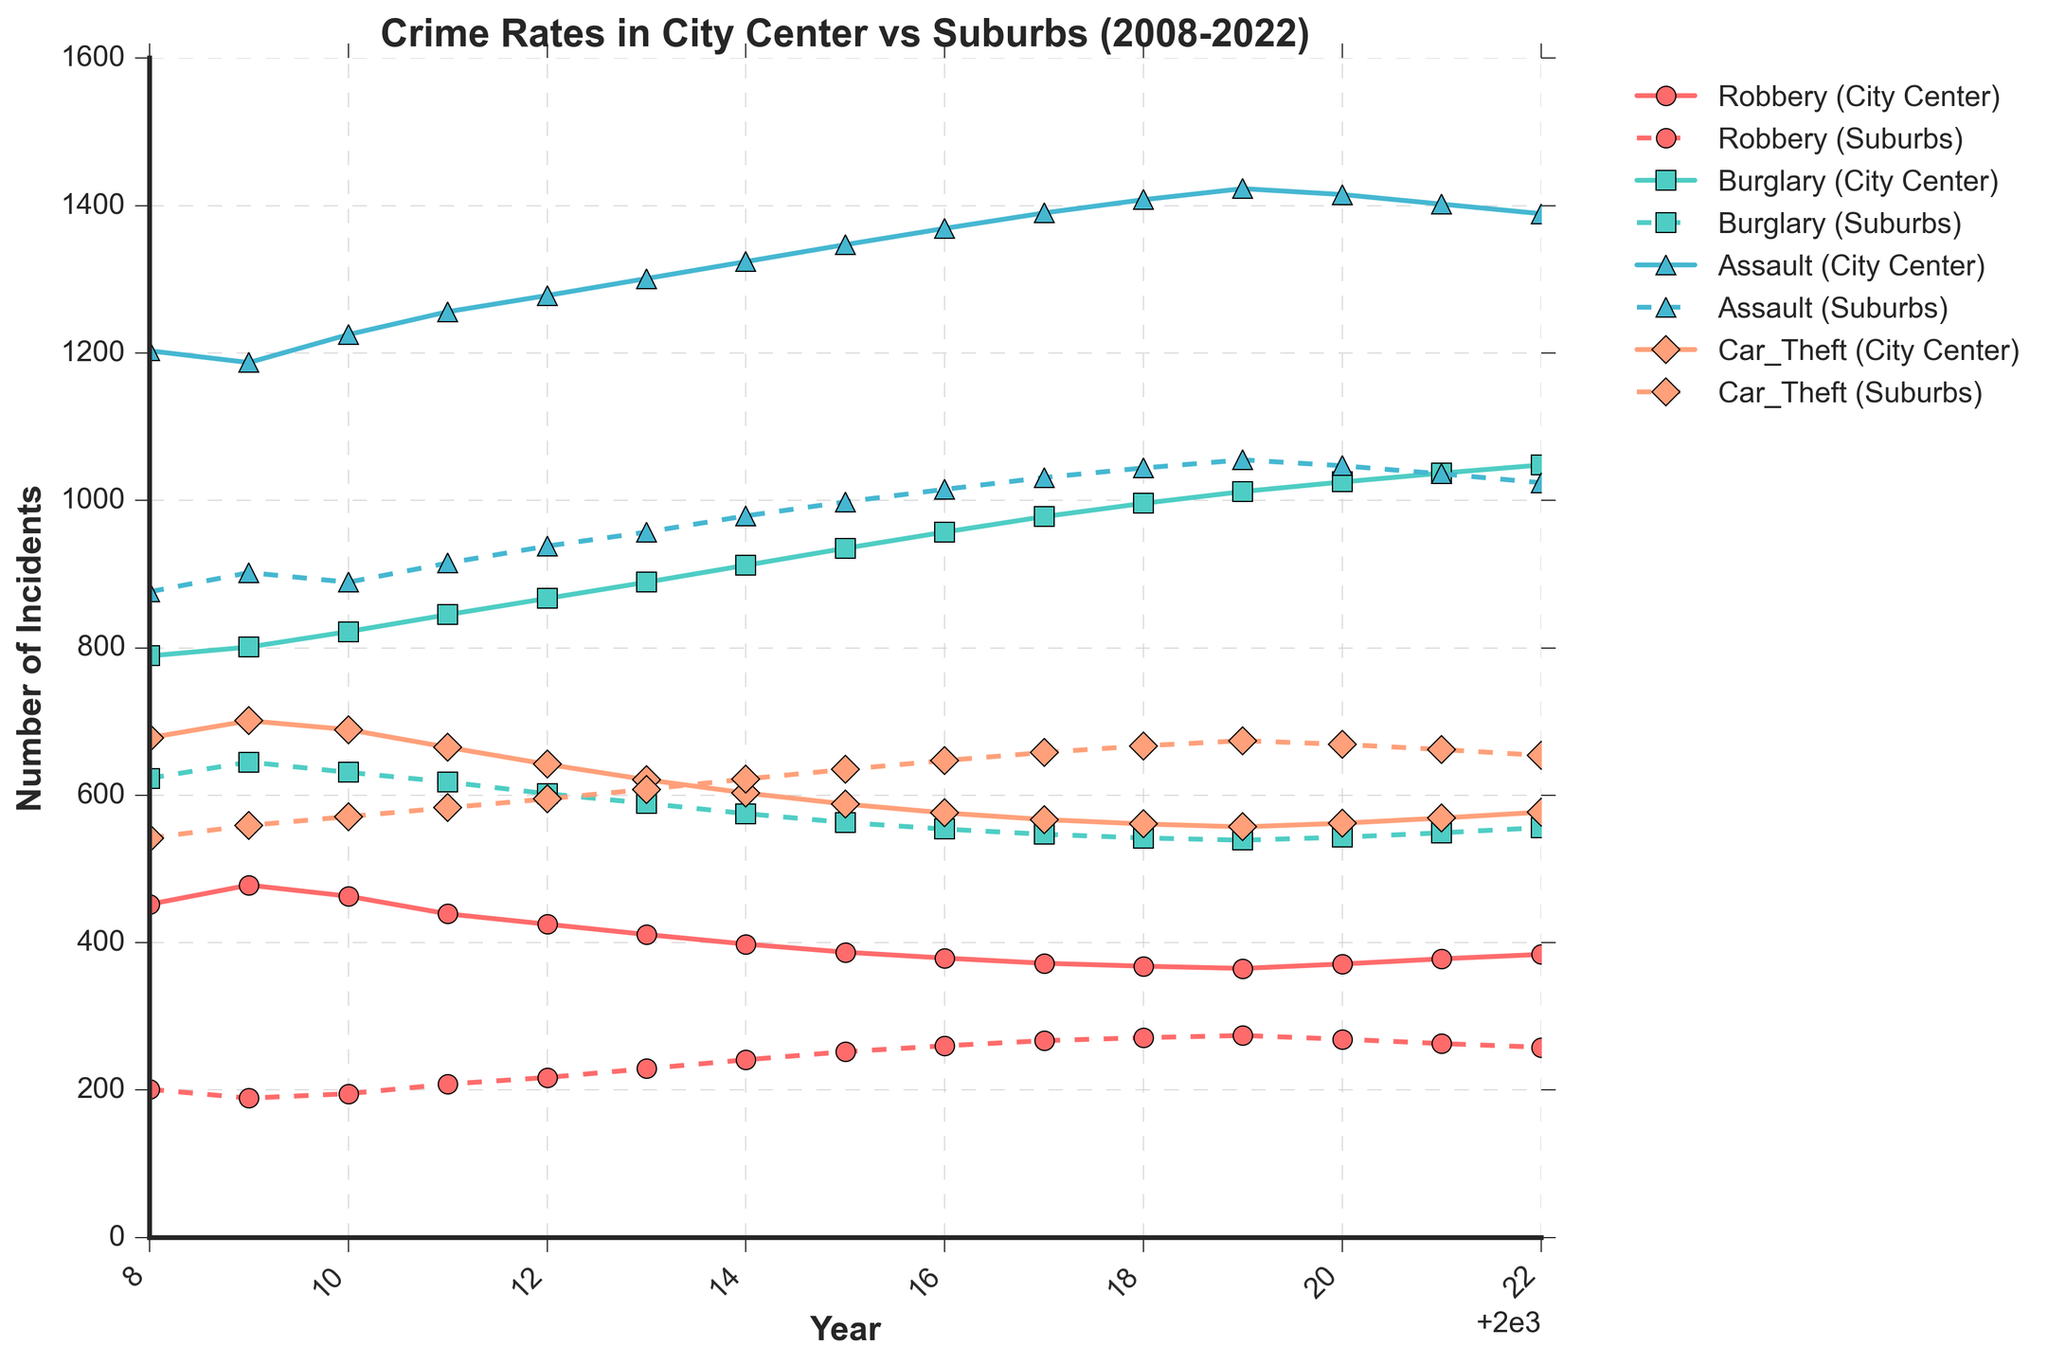Which year had the highest number of Robbery incidents in the city center? By looking at the 'Robbery (City Center)' line on the chart, the peak point represents the year with the highest number of incidents.
Answer: 2009 What is the difference between Burglary incidents in the suburbs and the city center in 2014? For 2014, from the chart, Burglary incidents in the suburbs are fewer than the city center. Subtract the city center's value from the suburbs' value: 912 - 575.
Answer: 337 Do Assault incidents in the suburbs ever surpass those in the city center throughout the years? Observe the two lines corresponding to 'Assault' incidents in the city center and suburbs for any intersection point. Since the center line is always higher, the suburbs never surpass the center.
Answer: No What's the average number of Car Theft incidents in the city center over these years? Calculate the mean by summing up all values from the 'Car Theft (City Center)' line and dividing by the number of years (15). (678 + 701 + ... + 577)/15.
Answer: 624.87 Which type of crime shows the least fluctuation in the suburbs over the years? By comparing the four 'Suburbs' lines, look for the line that stays relatively flat with minimal ups and downs. 'Car Theft (Suburbs)' appears to be the flattest.
Answer: Car Theft In which year do the Robbery incidents in the city center and suburbs have the smallest difference? Look for the year where the gap between 'Robbery (City Center)' and 'Robbery (Suburbs)' lines is narrowest. It appears to be in 2017.
Answer: 2017 Is the trend of Assault incidents in the suburbs increasing, decreasing, or staying constant? Observe the 'Assault (Suburbs)' line from left to right. It generally trends upwards, indicating an increase.
Answer: Increasing What's the combined total of Robbery and Burglary incidents in the city center in 2018? Add 'Robbery (City Center)' and 'Burglary (City Center)' values for 2018: 368 + 996.
Answer: 1364 How does the number of Robbery incidents in the city center in 2010 compare to Car Theft incidents in the suburbs the same year? Find the values for 'Robbery (City Center)' and 'Car Theft (Suburbs)' for 2010, then compare: 463 is greater than 571.
Answer: Greater 